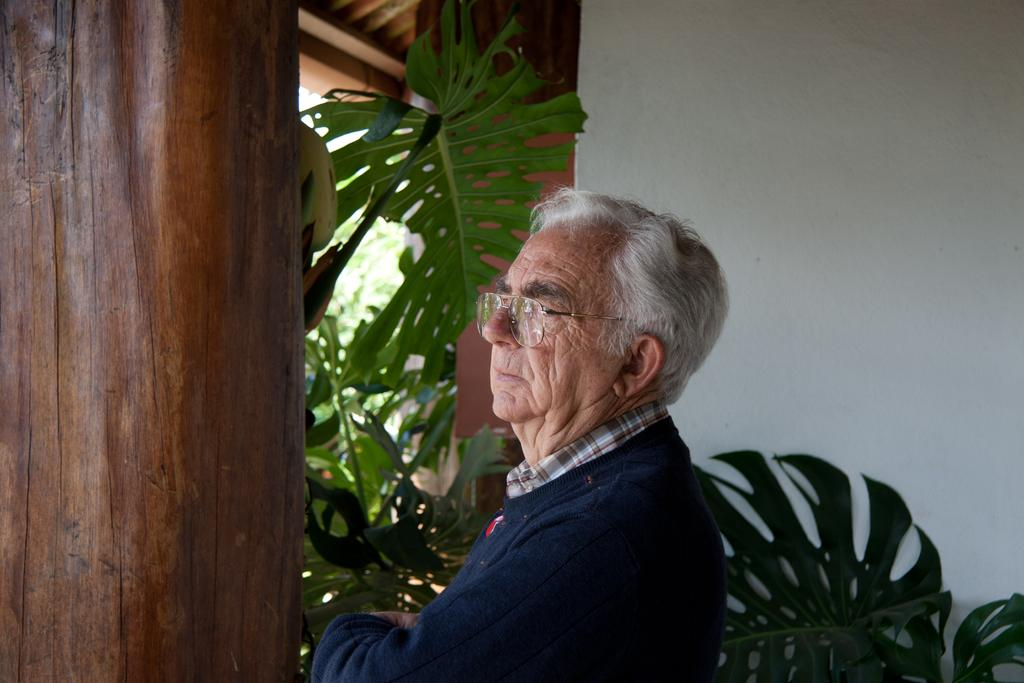What is the main subject of the image? There is a person in the image. What can be seen behind the person? There is a wooden object behind the person. What type of vegetation is visible in the image? There are plants visible in the image. What is the background of the image composed of? There is a wall in the background of the image. What type of roof is visible in the image? The wooden roof is visible at the top of the image. What condition is the group of people in the image? There is no group of people present in the image; it only features a single person. 